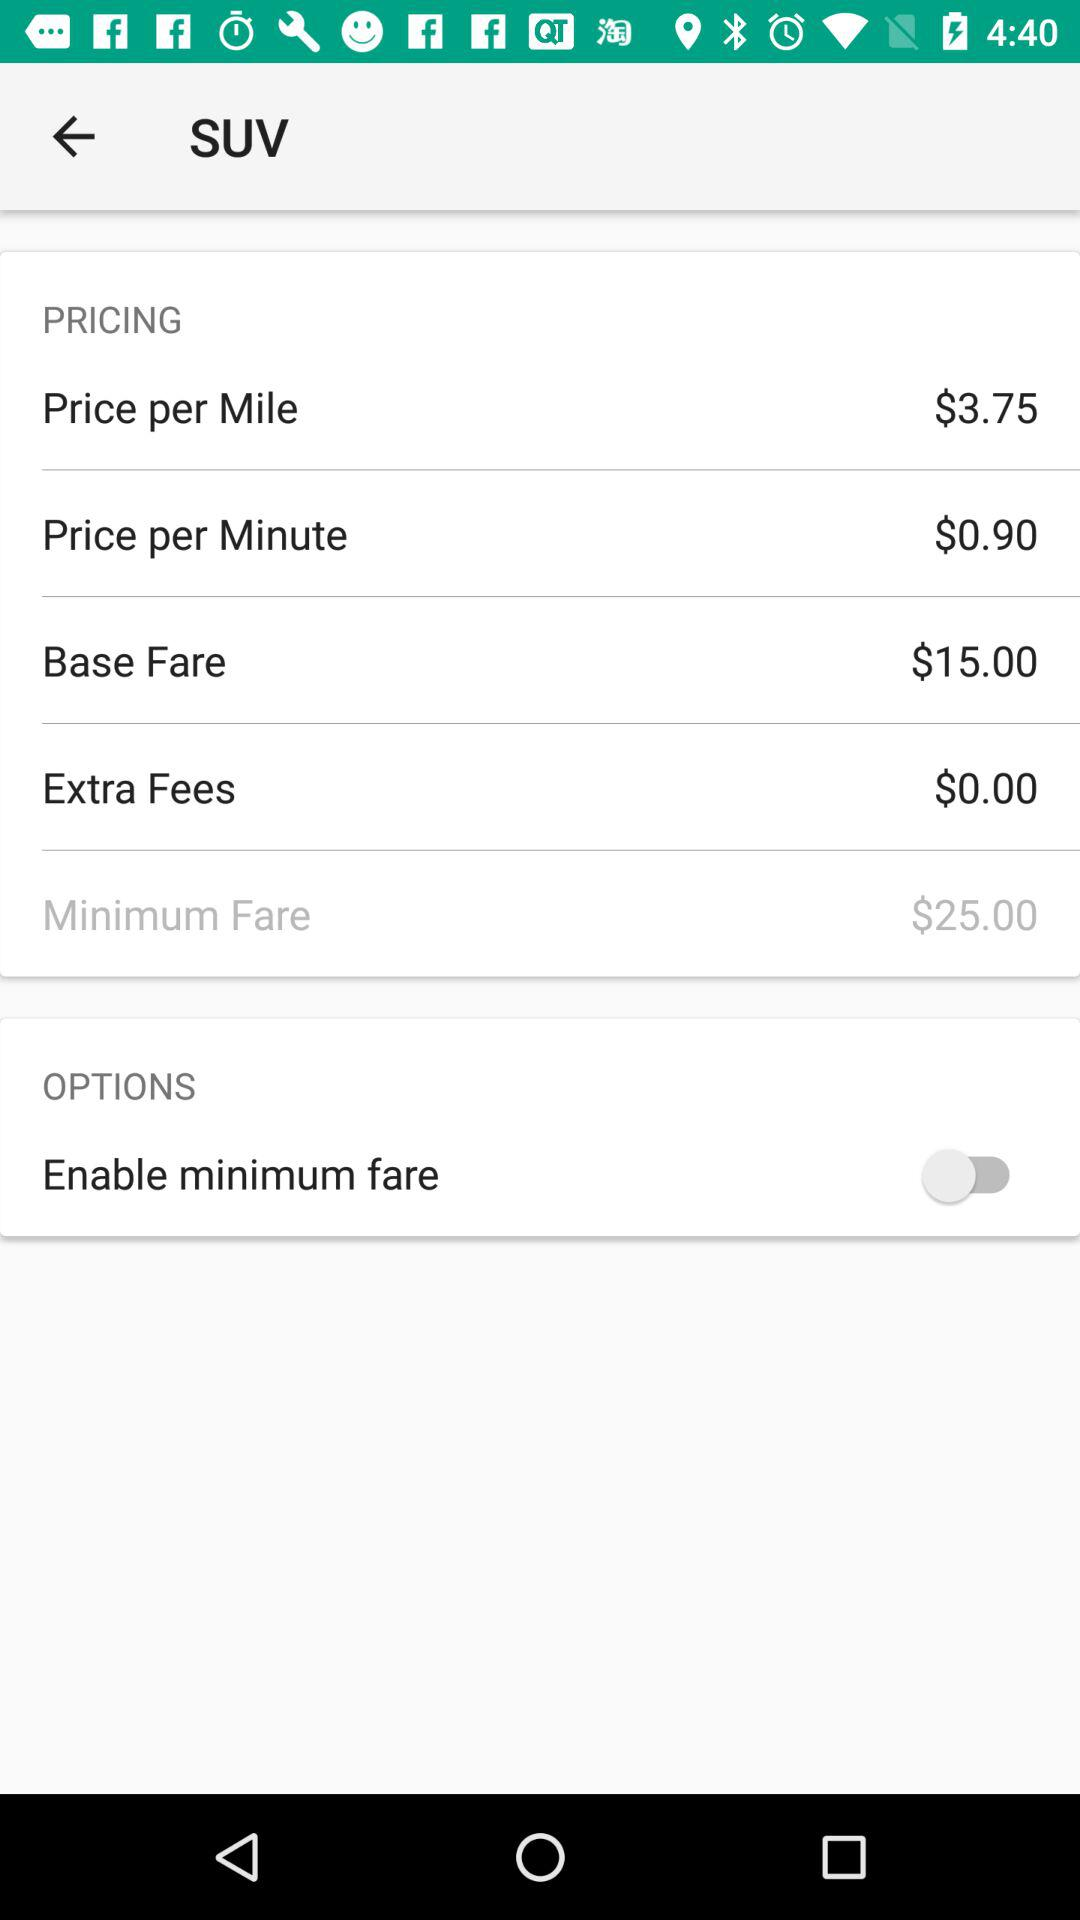How much is the base fare?
Answer the question using a single word or phrase. $15.00 